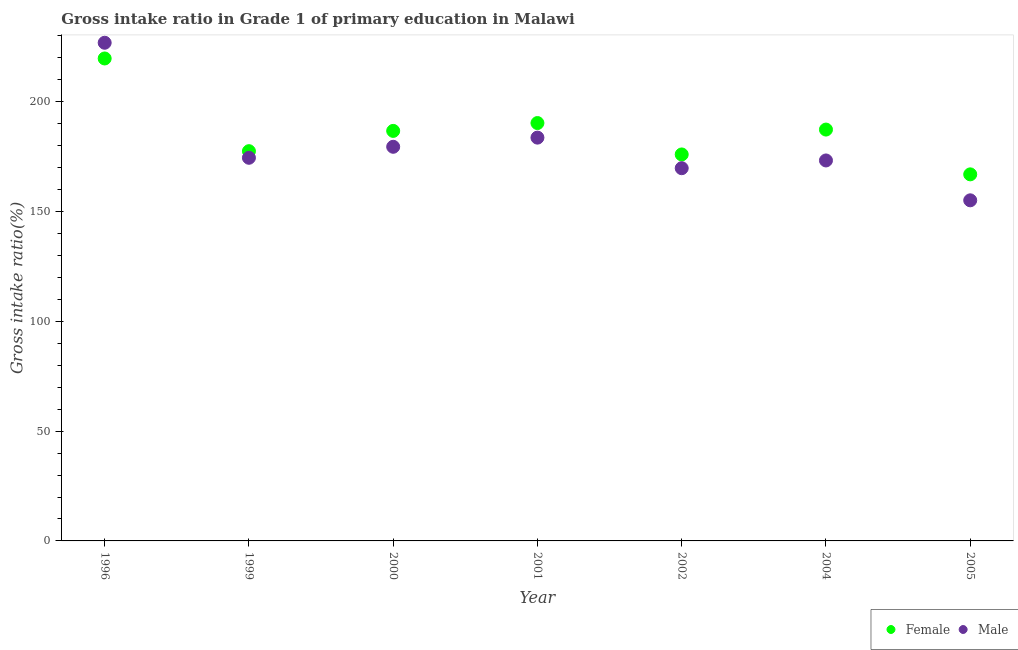How many different coloured dotlines are there?
Offer a terse response. 2. Is the number of dotlines equal to the number of legend labels?
Provide a succinct answer. Yes. What is the gross intake ratio(female) in 2000?
Keep it short and to the point. 186.74. Across all years, what is the maximum gross intake ratio(female)?
Make the answer very short. 219.72. Across all years, what is the minimum gross intake ratio(female)?
Make the answer very short. 166.94. In which year was the gross intake ratio(female) minimum?
Provide a short and direct response. 2005. What is the total gross intake ratio(female) in the graph?
Ensure brevity in your answer.  1304.58. What is the difference between the gross intake ratio(female) in 2000 and that in 2001?
Ensure brevity in your answer.  -3.57. What is the difference between the gross intake ratio(male) in 2001 and the gross intake ratio(female) in 2000?
Ensure brevity in your answer.  -3.07. What is the average gross intake ratio(female) per year?
Your response must be concise. 186.37. In the year 1996, what is the difference between the gross intake ratio(male) and gross intake ratio(female)?
Make the answer very short. 7.16. What is the ratio of the gross intake ratio(female) in 1996 to that in 2002?
Make the answer very short. 1.25. Is the gross intake ratio(female) in 1996 less than that in 2001?
Make the answer very short. No. Is the difference between the gross intake ratio(female) in 1999 and 2000 greater than the difference between the gross intake ratio(male) in 1999 and 2000?
Your answer should be compact. No. What is the difference between the highest and the second highest gross intake ratio(female)?
Your answer should be compact. 29.41. What is the difference between the highest and the lowest gross intake ratio(female)?
Your answer should be very brief. 52.78. Is the gross intake ratio(male) strictly greater than the gross intake ratio(female) over the years?
Keep it short and to the point. No. Is the gross intake ratio(male) strictly less than the gross intake ratio(female) over the years?
Offer a terse response. No. How many dotlines are there?
Give a very brief answer. 2. What is the difference between two consecutive major ticks on the Y-axis?
Keep it short and to the point. 50. Are the values on the major ticks of Y-axis written in scientific E-notation?
Ensure brevity in your answer.  No. Does the graph contain any zero values?
Make the answer very short. No. Does the graph contain grids?
Provide a succinct answer. No. Where does the legend appear in the graph?
Keep it short and to the point. Bottom right. What is the title of the graph?
Keep it short and to the point. Gross intake ratio in Grade 1 of primary education in Malawi. What is the label or title of the X-axis?
Ensure brevity in your answer.  Year. What is the label or title of the Y-axis?
Offer a very short reply. Gross intake ratio(%). What is the Gross intake ratio(%) in Female in 1996?
Provide a succinct answer. 219.72. What is the Gross intake ratio(%) in Male in 1996?
Provide a succinct answer. 226.88. What is the Gross intake ratio(%) in Female in 1999?
Offer a very short reply. 177.5. What is the Gross intake ratio(%) in Male in 1999?
Offer a terse response. 174.49. What is the Gross intake ratio(%) in Female in 2000?
Your response must be concise. 186.74. What is the Gross intake ratio(%) of Male in 2000?
Your answer should be compact. 179.5. What is the Gross intake ratio(%) of Female in 2001?
Your answer should be compact. 190.31. What is the Gross intake ratio(%) of Male in 2001?
Make the answer very short. 183.67. What is the Gross intake ratio(%) of Female in 2002?
Keep it short and to the point. 176.01. What is the Gross intake ratio(%) of Male in 2002?
Offer a terse response. 169.75. What is the Gross intake ratio(%) in Female in 2004?
Make the answer very short. 187.34. What is the Gross intake ratio(%) of Male in 2004?
Offer a terse response. 173.28. What is the Gross intake ratio(%) in Female in 2005?
Your response must be concise. 166.94. What is the Gross intake ratio(%) in Male in 2005?
Give a very brief answer. 155.12. Across all years, what is the maximum Gross intake ratio(%) in Female?
Offer a very short reply. 219.72. Across all years, what is the maximum Gross intake ratio(%) of Male?
Provide a succinct answer. 226.88. Across all years, what is the minimum Gross intake ratio(%) of Female?
Offer a very short reply. 166.94. Across all years, what is the minimum Gross intake ratio(%) in Male?
Provide a short and direct response. 155.12. What is the total Gross intake ratio(%) in Female in the graph?
Provide a succinct answer. 1304.58. What is the total Gross intake ratio(%) of Male in the graph?
Your answer should be compact. 1262.69. What is the difference between the Gross intake ratio(%) of Female in 1996 and that in 1999?
Offer a very short reply. 42.22. What is the difference between the Gross intake ratio(%) of Male in 1996 and that in 1999?
Offer a very short reply. 52.39. What is the difference between the Gross intake ratio(%) in Female in 1996 and that in 2000?
Your answer should be compact. 32.98. What is the difference between the Gross intake ratio(%) in Male in 1996 and that in 2000?
Your answer should be very brief. 47.38. What is the difference between the Gross intake ratio(%) in Female in 1996 and that in 2001?
Offer a very short reply. 29.41. What is the difference between the Gross intake ratio(%) of Male in 1996 and that in 2001?
Your answer should be compact. 43.21. What is the difference between the Gross intake ratio(%) of Female in 1996 and that in 2002?
Your answer should be compact. 43.71. What is the difference between the Gross intake ratio(%) of Male in 1996 and that in 2002?
Your response must be concise. 57.13. What is the difference between the Gross intake ratio(%) in Female in 1996 and that in 2004?
Your answer should be compact. 32.38. What is the difference between the Gross intake ratio(%) in Male in 1996 and that in 2004?
Keep it short and to the point. 53.61. What is the difference between the Gross intake ratio(%) of Female in 1996 and that in 2005?
Your answer should be compact. 52.78. What is the difference between the Gross intake ratio(%) of Male in 1996 and that in 2005?
Provide a succinct answer. 71.76. What is the difference between the Gross intake ratio(%) of Female in 1999 and that in 2000?
Make the answer very short. -9.24. What is the difference between the Gross intake ratio(%) in Male in 1999 and that in 2000?
Keep it short and to the point. -5.01. What is the difference between the Gross intake ratio(%) in Female in 1999 and that in 2001?
Provide a short and direct response. -12.81. What is the difference between the Gross intake ratio(%) of Male in 1999 and that in 2001?
Offer a very short reply. -9.18. What is the difference between the Gross intake ratio(%) of Female in 1999 and that in 2002?
Give a very brief answer. 1.49. What is the difference between the Gross intake ratio(%) in Male in 1999 and that in 2002?
Make the answer very short. 4.74. What is the difference between the Gross intake ratio(%) in Female in 1999 and that in 2004?
Ensure brevity in your answer.  -9.84. What is the difference between the Gross intake ratio(%) of Male in 1999 and that in 2004?
Offer a terse response. 1.21. What is the difference between the Gross intake ratio(%) in Female in 1999 and that in 2005?
Make the answer very short. 10.56. What is the difference between the Gross intake ratio(%) of Male in 1999 and that in 2005?
Your response must be concise. 19.37. What is the difference between the Gross intake ratio(%) in Female in 2000 and that in 2001?
Provide a succinct answer. -3.57. What is the difference between the Gross intake ratio(%) of Male in 2000 and that in 2001?
Provide a succinct answer. -4.17. What is the difference between the Gross intake ratio(%) in Female in 2000 and that in 2002?
Provide a succinct answer. 10.73. What is the difference between the Gross intake ratio(%) of Male in 2000 and that in 2002?
Give a very brief answer. 9.75. What is the difference between the Gross intake ratio(%) of Female in 2000 and that in 2004?
Your answer should be compact. -0.6. What is the difference between the Gross intake ratio(%) in Male in 2000 and that in 2004?
Offer a very short reply. 6.22. What is the difference between the Gross intake ratio(%) of Female in 2000 and that in 2005?
Your response must be concise. 19.79. What is the difference between the Gross intake ratio(%) of Male in 2000 and that in 2005?
Make the answer very short. 24.38. What is the difference between the Gross intake ratio(%) of Female in 2001 and that in 2002?
Provide a succinct answer. 14.3. What is the difference between the Gross intake ratio(%) of Male in 2001 and that in 2002?
Make the answer very short. 13.92. What is the difference between the Gross intake ratio(%) of Female in 2001 and that in 2004?
Ensure brevity in your answer.  2.97. What is the difference between the Gross intake ratio(%) of Male in 2001 and that in 2004?
Make the answer very short. 10.4. What is the difference between the Gross intake ratio(%) in Female in 2001 and that in 2005?
Offer a terse response. 23.37. What is the difference between the Gross intake ratio(%) of Male in 2001 and that in 2005?
Ensure brevity in your answer.  28.55. What is the difference between the Gross intake ratio(%) of Female in 2002 and that in 2004?
Keep it short and to the point. -11.33. What is the difference between the Gross intake ratio(%) in Male in 2002 and that in 2004?
Offer a terse response. -3.53. What is the difference between the Gross intake ratio(%) of Female in 2002 and that in 2005?
Your answer should be compact. 9.07. What is the difference between the Gross intake ratio(%) of Male in 2002 and that in 2005?
Offer a terse response. 14.63. What is the difference between the Gross intake ratio(%) of Female in 2004 and that in 2005?
Your response must be concise. 20.4. What is the difference between the Gross intake ratio(%) of Male in 2004 and that in 2005?
Your answer should be very brief. 18.15. What is the difference between the Gross intake ratio(%) in Female in 1996 and the Gross intake ratio(%) in Male in 1999?
Offer a very short reply. 45.23. What is the difference between the Gross intake ratio(%) of Female in 1996 and the Gross intake ratio(%) of Male in 2000?
Ensure brevity in your answer.  40.22. What is the difference between the Gross intake ratio(%) in Female in 1996 and the Gross intake ratio(%) in Male in 2001?
Make the answer very short. 36.05. What is the difference between the Gross intake ratio(%) in Female in 1996 and the Gross intake ratio(%) in Male in 2002?
Ensure brevity in your answer.  49.97. What is the difference between the Gross intake ratio(%) in Female in 1996 and the Gross intake ratio(%) in Male in 2004?
Your answer should be compact. 46.45. What is the difference between the Gross intake ratio(%) in Female in 1996 and the Gross intake ratio(%) in Male in 2005?
Make the answer very short. 64.6. What is the difference between the Gross intake ratio(%) in Female in 1999 and the Gross intake ratio(%) in Male in 2000?
Give a very brief answer. -2. What is the difference between the Gross intake ratio(%) of Female in 1999 and the Gross intake ratio(%) of Male in 2001?
Your response must be concise. -6.17. What is the difference between the Gross intake ratio(%) of Female in 1999 and the Gross intake ratio(%) of Male in 2002?
Provide a succinct answer. 7.75. What is the difference between the Gross intake ratio(%) in Female in 1999 and the Gross intake ratio(%) in Male in 2004?
Your answer should be compact. 4.23. What is the difference between the Gross intake ratio(%) in Female in 1999 and the Gross intake ratio(%) in Male in 2005?
Your answer should be very brief. 22.38. What is the difference between the Gross intake ratio(%) in Female in 2000 and the Gross intake ratio(%) in Male in 2001?
Give a very brief answer. 3.07. What is the difference between the Gross intake ratio(%) in Female in 2000 and the Gross intake ratio(%) in Male in 2002?
Give a very brief answer. 16.99. What is the difference between the Gross intake ratio(%) in Female in 2000 and the Gross intake ratio(%) in Male in 2004?
Provide a short and direct response. 13.46. What is the difference between the Gross intake ratio(%) in Female in 2000 and the Gross intake ratio(%) in Male in 2005?
Offer a very short reply. 31.62. What is the difference between the Gross intake ratio(%) in Female in 2001 and the Gross intake ratio(%) in Male in 2002?
Your response must be concise. 20.56. What is the difference between the Gross intake ratio(%) of Female in 2001 and the Gross intake ratio(%) of Male in 2004?
Make the answer very short. 17.04. What is the difference between the Gross intake ratio(%) of Female in 2001 and the Gross intake ratio(%) of Male in 2005?
Your answer should be compact. 35.19. What is the difference between the Gross intake ratio(%) of Female in 2002 and the Gross intake ratio(%) of Male in 2004?
Your response must be concise. 2.74. What is the difference between the Gross intake ratio(%) in Female in 2002 and the Gross intake ratio(%) in Male in 2005?
Ensure brevity in your answer.  20.89. What is the difference between the Gross intake ratio(%) of Female in 2004 and the Gross intake ratio(%) of Male in 2005?
Ensure brevity in your answer.  32.22. What is the average Gross intake ratio(%) of Female per year?
Give a very brief answer. 186.37. What is the average Gross intake ratio(%) in Male per year?
Your response must be concise. 180.38. In the year 1996, what is the difference between the Gross intake ratio(%) in Female and Gross intake ratio(%) in Male?
Offer a terse response. -7.16. In the year 1999, what is the difference between the Gross intake ratio(%) of Female and Gross intake ratio(%) of Male?
Your response must be concise. 3.01. In the year 2000, what is the difference between the Gross intake ratio(%) in Female and Gross intake ratio(%) in Male?
Your answer should be very brief. 7.24. In the year 2001, what is the difference between the Gross intake ratio(%) in Female and Gross intake ratio(%) in Male?
Your answer should be very brief. 6.64. In the year 2002, what is the difference between the Gross intake ratio(%) of Female and Gross intake ratio(%) of Male?
Your response must be concise. 6.26. In the year 2004, what is the difference between the Gross intake ratio(%) in Female and Gross intake ratio(%) in Male?
Provide a succinct answer. 14.07. In the year 2005, what is the difference between the Gross intake ratio(%) in Female and Gross intake ratio(%) in Male?
Provide a succinct answer. 11.82. What is the ratio of the Gross intake ratio(%) of Female in 1996 to that in 1999?
Your answer should be very brief. 1.24. What is the ratio of the Gross intake ratio(%) in Male in 1996 to that in 1999?
Offer a terse response. 1.3. What is the ratio of the Gross intake ratio(%) of Female in 1996 to that in 2000?
Ensure brevity in your answer.  1.18. What is the ratio of the Gross intake ratio(%) of Male in 1996 to that in 2000?
Your response must be concise. 1.26. What is the ratio of the Gross intake ratio(%) of Female in 1996 to that in 2001?
Provide a succinct answer. 1.15. What is the ratio of the Gross intake ratio(%) in Male in 1996 to that in 2001?
Offer a terse response. 1.24. What is the ratio of the Gross intake ratio(%) in Female in 1996 to that in 2002?
Your answer should be very brief. 1.25. What is the ratio of the Gross intake ratio(%) in Male in 1996 to that in 2002?
Provide a short and direct response. 1.34. What is the ratio of the Gross intake ratio(%) of Female in 1996 to that in 2004?
Offer a terse response. 1.17. What is the ratio of the Gross intake ratio(%) of Male in 1996 to that in 2004?
Offer a terse response. 1.31. What is the ratio of the Gross intake ratio(%) of Female in 1996 to that in 2005?
Your response must be concise. 1.32. What is the ratio of the Gross intake ratio(%) in Male in 1996 to that in 2005?
Provide a succinct answer. 1.46. What is the ratio of the Gross intake ratio(%) of Female in 1999 to that in 2000?
Give a very brief answer. 0.95. What is the ratio of the Gross intake ratio(%) of Male in 1999 to that in 2000?
Offer a very short reply. 0.97. What is the ratio of the Gross intake ratio(%) of Female in 1999 to that in 2001?
Provide a succinct answer. 0.93. What is the ratio of the Gross intake ratio(%) of Female in 1999 to that in 2002?
Provide a short and direct response. 1.01. What is the ratio of the Gross intake ratio(%) of Male in 1999 to that in 2002?
Provide a succinct answer. 1.03. What is the ratio of the Gross intake ratio(%) in Female in 1999 to that in 2004?
Make the answer very short. 0.95. What is the ratio of the Gross intake ratio(%) in Female in 1999 to that in 2005?
Offer a terse response. 1.06. What is the ratio of the Gross intake ratio(%) of Male in 1999 to that in 2005?
Your answer should be compact. 1.12. What is the ratio of the Gross intake ratio(%) in Female in 2000 to that in 2001?
Offer a terse response. 0.98. What is the ratio of the Gross intake ratio(%) in Male in 2000 to that in 2001?
Your answer should be very brief. 0.98. What is the ratio of the Gross intake ratio(%) of Female in 2000 to that in 2002?
Provide a short and direct response. 1.06. What is the ratio of the Gross intake ratio(%) of Male in 2000 to that in 2002?
Provide a short and direct response. 1.06. What is the ratio of the Gross intake ratio(%) in Male in 2000 to that in 2004?
Provide a short and direct response. 1.04. What is the ratio of the Gross intake ratio(%) in Female in 2000 to that in 2005?
Ensure brevity in your answer.  1.12. What is the ratio of the Gross intake ratio(%) of Male in 2000 to that in 2005?
Offer a very short reply. 1.16. What is the ratio of the Gross intake ratio(%) of Female in 2001 to that in 2002?
Your answer should be very brief. 1.08. What is the ratio of the Gross intake ratio(%) of Male in 2001 to that in 2002?
Give a very brief answer. 1.08. What is the ratio of the Gross intake ratio(%) in Female in 2001 to that in 2004?
Give a very brief answer. 1.02. What is the ratio of the Gross intake ratio(%) of Male in 2001 to that in 2004?
Ensure brevity in your answer.  1.06. What is the ratio of the Gross intake ratio(%) of Female in 2001 to that in 2005?
Ensure brevity in your answer.  1.14. What is the ratio of the Gross intake ratio(%) in Male in 2001 to that in 2005?
Keep it short and to the point. 1.18. What is the ratio of the Gross intake ratio(%) in Female in 2002 to that in 2004?
Ensure brevity in your answer.  0.94. What is the ratio of the Gross intake ratio(%) of Male in 2002 to that in 2004?
Your answer should be compact. 0.98. What is the ratio of the Gross intake ratio(%) of Female in 2002 to that in 2005?
Keep it short and to the point. 1.05. What is the ratio of the Gross intake ratio(%) of Male in 2002 to that in 2005?
Provide a short and direct response. 1.09. What is the ratio of the Gross intake ratio(%) in Female in 2004 to that in 2005?
Your answer should be very brief. 1.12. What is the ratio of the Gross intake ratio(%) of Male in 2004 to that in 2005?
Offer a terse response. 1.12. What is the difference between the highest and the second highest Gross intake ratio(%) of Female?
Keep it short and to the point. 29.41. What is the difference between the highest and the second highest Gross intake ratio(%) in Male?
Your response must be concise. 43.21. What is the difference between the highest and the lowest Gross intake ratio(%) in Female?
Your answer should be compact. 52.78. What is the difference between the highest and the lowest Gross intake ratio(%) in Male?
Offer a very short reply. 71.76. 